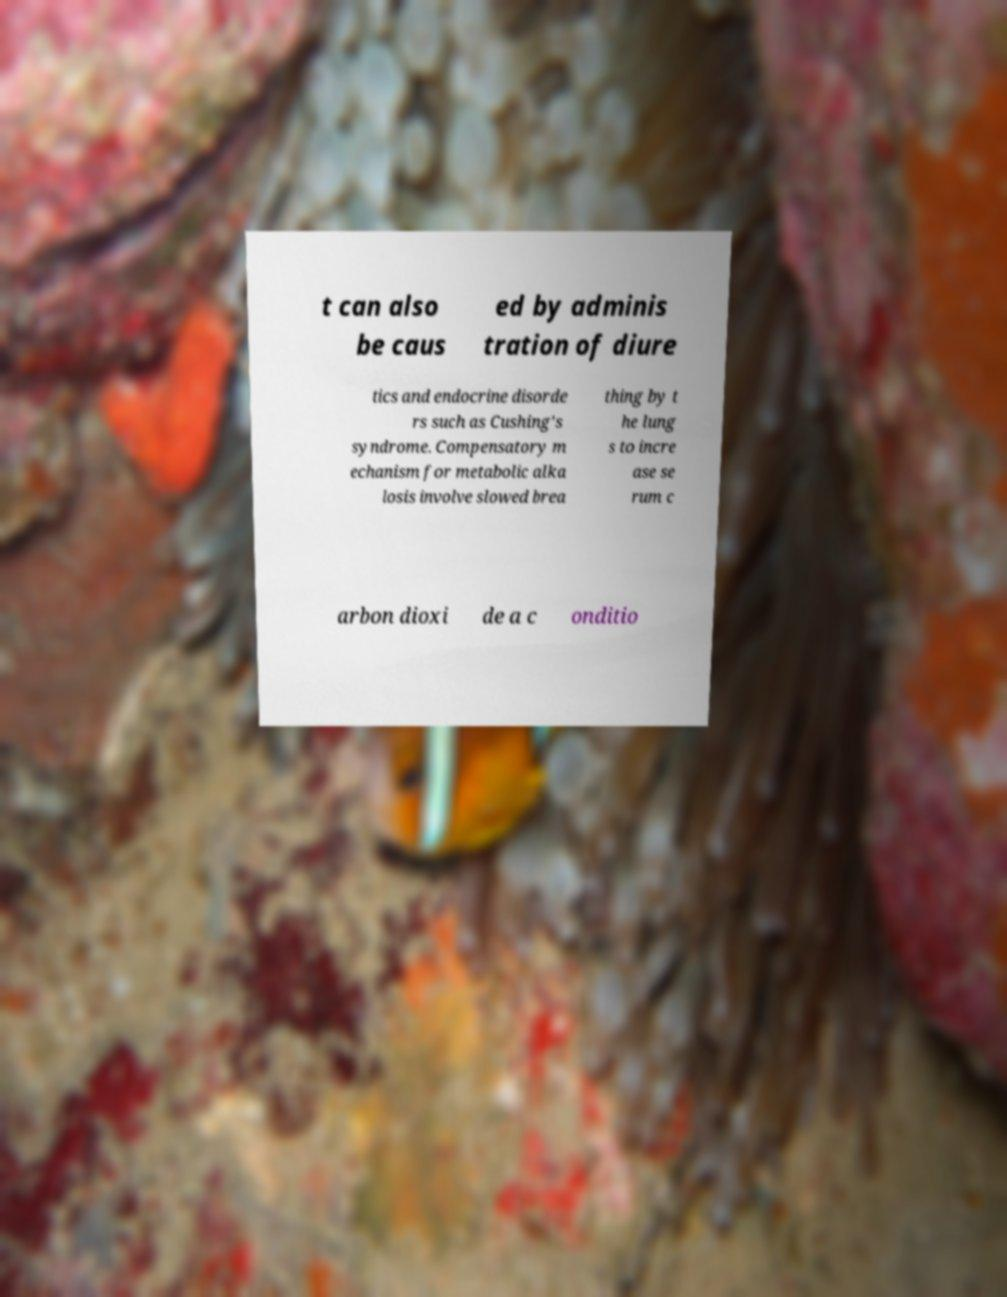Can you read and provide the text displayed in the image?This photo seems to have some interesting text. Can you extract and type it out for me? t can also be caus ed by adminis tration of diure tics and endocrine disorde rs such as Cushing's syndrome. Compensatory m echanism for metabolic alka losis involve slowed brea thing by t he lung s to incre ase se rum c arbon dioxi de a c onditio 